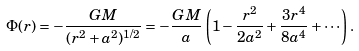Convert formula to latex. <formula><loc_0><loc_0><loc_500><loc_500>\Phi ( r ) = - \frac { G M } { ( r ^ { 2 } + a ^ { 2 } ) ^ { 1 / 2 } } = - \frac { G M } { a } \left ( 1 - \frac { r ^ { 2 } } { 2 a ^ { 2 } } + \frac { 3 r ^ { 4 } } { 8 a ^ { 4 } } + \cdots \right ) .</formula> 